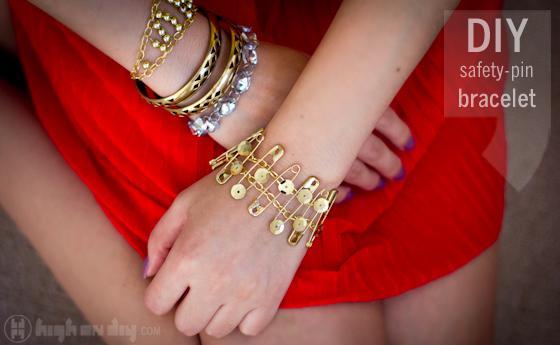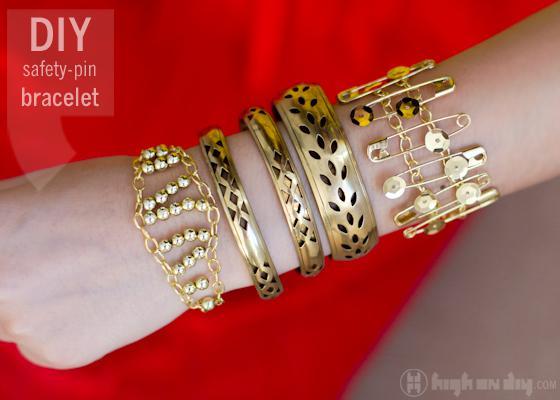The first image is the image on the left, the second image is the image on the right. Examine the images to the left and right. Is the description "The image on the right contains a bracelet with green beads on it." accurate? Answer yes or no. No. 